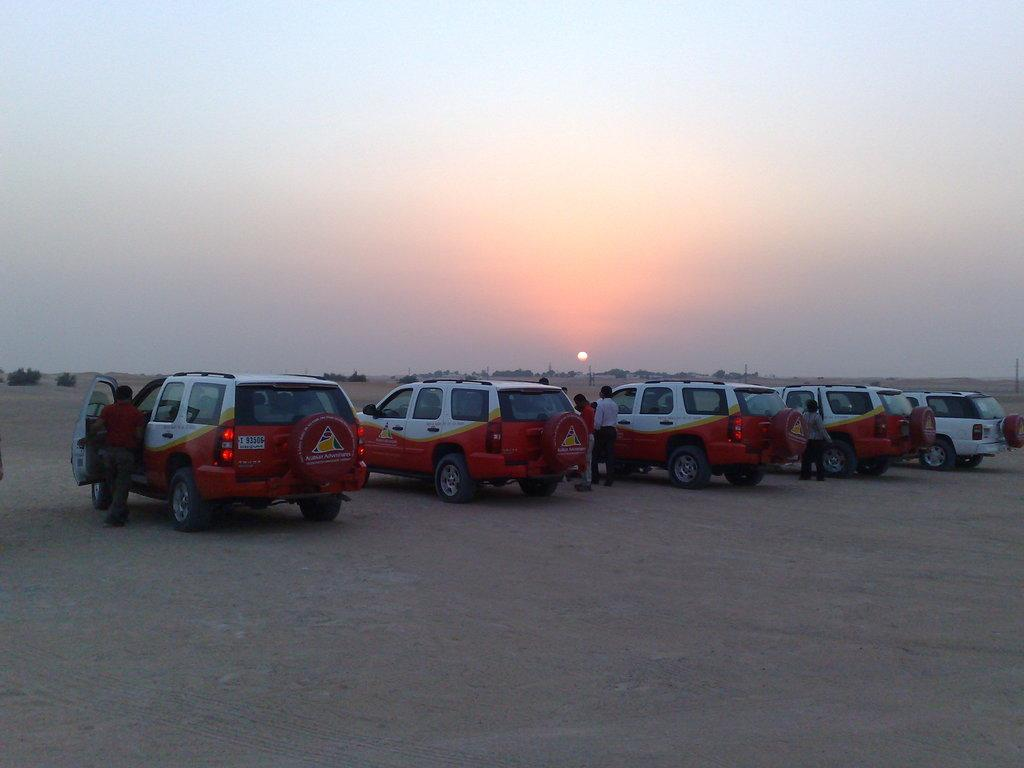What types of objects can be seen in the image? There are vehicles and people in the image. What can be seen in the background of the image? There are trees in the background of the image. What is visible in the sky in the image? The sun is visible in the image, and there is sky visible as well. What type of oil can be seen dripping from the seashore in the image? There is no seashore or oil present in the image. 